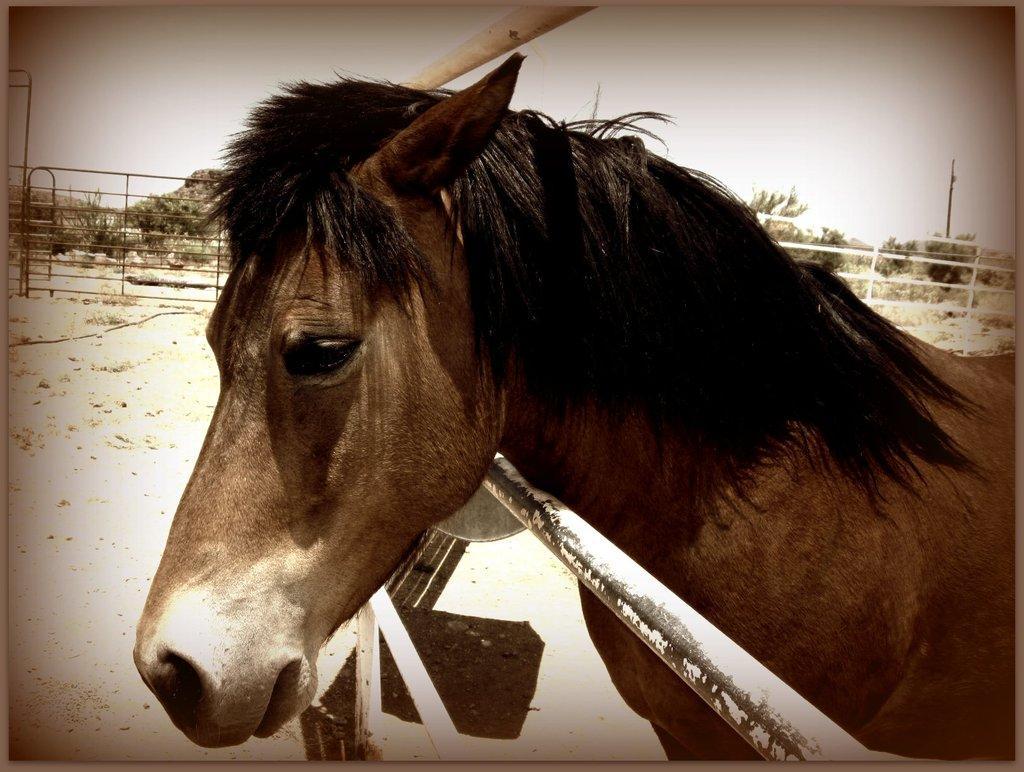Can you describe this image briefly? In this picture there is a horse and there is a white pole below and above its neck and there is a fence and trees in the background. 